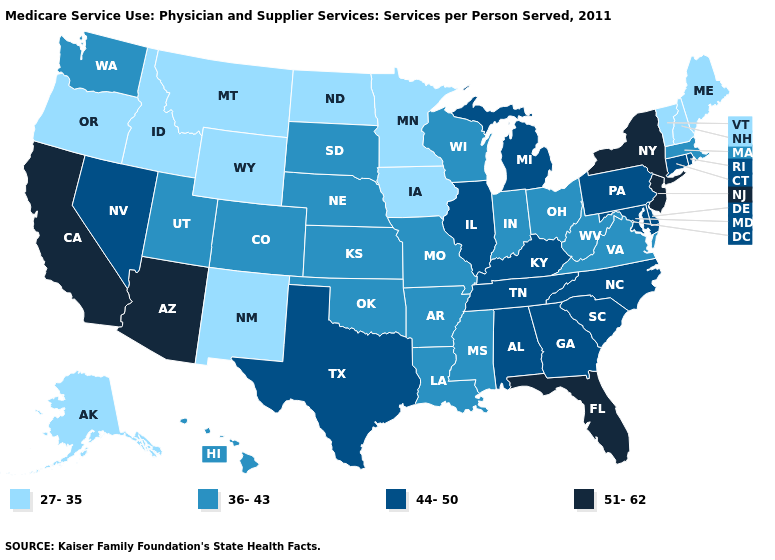Name the states that have a value in the range 36-43?
Short answer required. Arkansas, Colorado, Hawaii, Indiana, Kansas, Louisiana, Massachusetts, Mississippi, Missouri, Nebraska, Ohio, Oklahoma, South Dakota, Utah, Virginia, Washington, West Virginia, Wisconsin. Name the states that have a value in the range 51-62?
Short answer required. Arizona, California, Florida, New Jersey, New York. What is the value of Pennsylvania?
Short answer required. 44-50. What is the lowest value in the USA?
Give a very brief answer. 27-35. Does the map have missing data?
Be succinct. No. Name the states that have a value in the range 27-35?
Be succinct. Alaska, Idaho, Iowa, Maine, Minnesota, Montana, New Hampshire, New Mexico, North Dakota, Oregon, Vermont, Wyoming. Does Massachusetts have the lowest value in the Northeast?
Short answer required. No. Name the states that have a value in the range 44-50?
Answer briefly. Alabama, Connecticut, Delaware, Georgia, Illinois, Kentucky, Maryland, Michigan, Nevada, North Carolina, Pennsylvania, Rhode Island, South Carolina, Tennessee, Texas. Which states have the lowest value in the MidWest?
Quick response, please. Iowa, Minnesota, North Dakota. Does Minnesota have the lowest value in the USA?
Be succinct. Yes. Among the states that border California , which have the lowest value?
Write a very short answer. Oregon. Does Pennsylvania have the highest value in the Northeast?
Write a very short answer. No. Name the states that have a value in the range 27-35?
Short answer required. Alaska, Idaho, Iowa, Maine, Minnesota, Montana, New Hampshire, New Mexico, North Dakota, Oregon, Vermont, Wyoming. Which states have the highest value in the USA?
Concise answer only. Arizona, California, Florida, New Jersey, New York. Name the states that have a value in the range 27-35?
Concise answer only. Alaska, Idaho, Iowa, Maine, Minnesota, Montana, New Hampshire, New Mexico, North Dakota, Oregon, Vermont, Wyoming. 